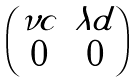<formula> <loc_0><loc_0><loc_500><loc_500>\begin{pmatrix} \nu c & \lambda d \\ 0 & 0 \end{pmatrix}</formula> 